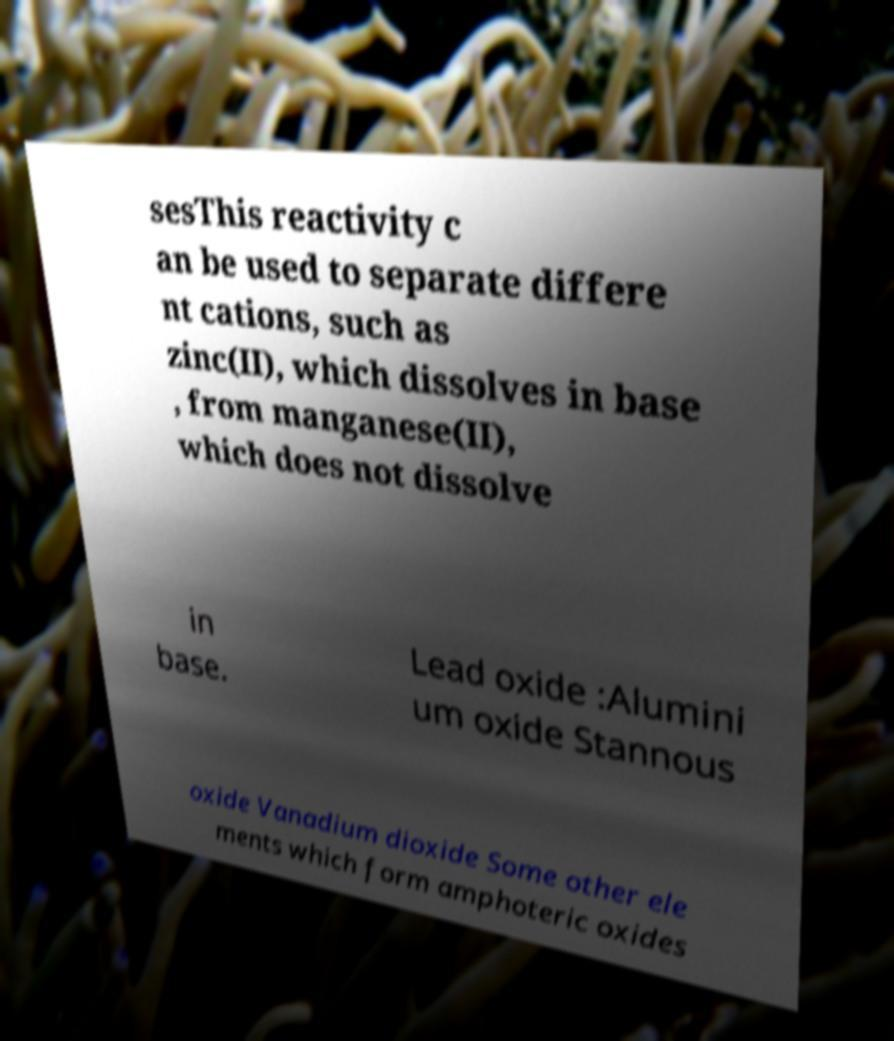Please identify and transcribe the text found in this image. sesThis reactivity c an be used to separate differe nt cations, such as zinc(II), which dissolves in base , from manganese(II), which does not dissolve in base. Lead oxide :Alumini um oxide Stannous oxide Vanadium dioxide Some other ele ments which form amphoteric oxides 